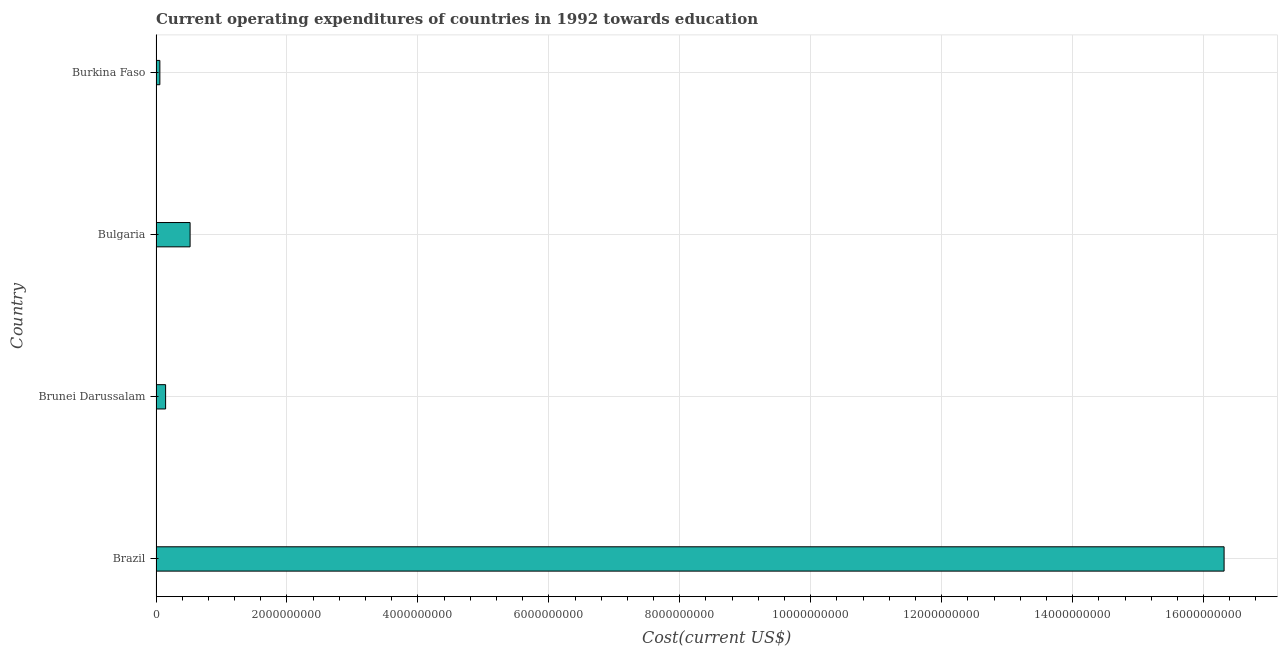Does the graph contain any zero values?
Offer a very short reply. No. Does the graph contain grids?
Your answer should be compact. Yes. What is the title of the graph?
Your answer should be very brief. Current operating expenditures of countries in 1992 towards education. What is the label or title of the X-axis?
Provide a short and direct response. Cost(current US$). What is the label or title of the Y-axis?
Make the answer very short. Country. What is the education expenditure in Bulgaria?
Offer a terse response. 5.20e+08. Across all countries, what is the maximum education expenditure?
Your answer should be compact. 1.63e+1. Across all countries, what is the minimum education expenditure?
Offer a terse response. 5.85e+07. In which country was the education expenditure maximum?
Provide a short and direct response. Brazil. In which country was the education expenditure minimum?
Offer a terse response. Burkina Faso. What is the sum of the education expenditure?
Provide a succinct answer. 1.70e+1. What is the difference between the education expenditure in Brunei Darussalam and Burkina Faso?
Give a very brief answer. 8.79e+07. What is the average education expenditure per country?
Give a very brief answer. 4.26e+09. What is the median education expenditure?
Keep it short and to the point. 3.33e+08. What is the ratio of the education expenditure in Brunei Darussalam to that in Bulgaria?
Provide a short and direct response. 0.28. Is the education expenditure in Brunei Darussalam less than that in Burkina Faso?
Ensure brevity in your answer.  No. Is the difference between the education expenditure in Bulgaria and Burkina Faso greater than the difference between any two countries?
Your answer should be compact. No. What is the difference between the highest and the second highest education expenditure?
Your answer should be compact. 1.58e+1. Is the sum of the education expenditure in Bulgaria and Burkina Faso greater than the maximum education expenditure across all countries?
Provide a succinct answer. No. What is the difference between the highest and the lowest education expenditure?
Offer a very short reply. 1.63e+1. In how many countries, is the education expenditure greater than the average education expenditure taken over all countries?
Ensure brevity in your answer.  1. Are all the bars in the graph horizontal?
Offer a very short reply. Yes. How many countries are there in the graph?
Provide a short and direct response. 4. What is the difference between two consecutive major ticks on the X-axis?
Offer a very short reply. 2.00e+09. Are the values on the major ticks of X-axis written in scientific E-notation?
Provide a succinct answer. No. What is the Cost(current US$) in Brazil?
Provide a succinct answer. 1.63e+1. What is the Cost(current US$) of Brunei Darussalam?
Offer a very short reply. 1.46e+08. What is the Cost(current US$) of Bulgaria?
Ensure brevity in your answer.  5.20e+08. What is the Cost(current US$) in Burkina Faso?
Your answer should be very brief. 5.85e+07. What is the difference between the Cost(current US$) in Brazil and Brunei Darussalam?
Give a very brief answer. 1.62e+1. What is the difference between the Cost(current US$) in Brazil and Bulgaria?
Offer a terse response. 1.58e+1. What is the difference between the Cost(current US$) in Brazil and Burkina Faso?
Provide a succinct answer. 1.63e+1. What is the difference between the Cost(current US$) in Brunei Darussalam and Bulgaria?
Offer a very short reply. -3.74e+08. What is the difference between the Cost(current US$) in Brunei Darussalam and Burkina Faso?
Ensure brevity in your answer.  8.79e+07. What is the difference between the Cost(current US$) in Bulgaria and Burkina Faso?
Keep it short and to the point. 4.62e+08. What is the ratio of the Cost(current US$) in Brazil to that in Brunei Darussalam?
Provide a succinct answer. 111.41. What is the ratio of the Cost(current US$) in Brazil to that in Bulgaria?
Keep it short and to the point. 31.35. What is the ratio of the Cost(current US$) in Brazil to that in Burkina Faso?
Your answer should be compact. 278.93. What is the ratio of the Cost(current US$) in Brunei Darussalam to that in Bulgaria?
Offer a terse response. 0.28. What is the ratio of the Cost(current US$) in Brunei Darussalam to that in Burkina Faso?
Your response must be concise. 2.5. What is the ratio of the Cost(current US$) in Bulgaria to that in Burkina Faso?
Provide a short and direct response. 8.9. 